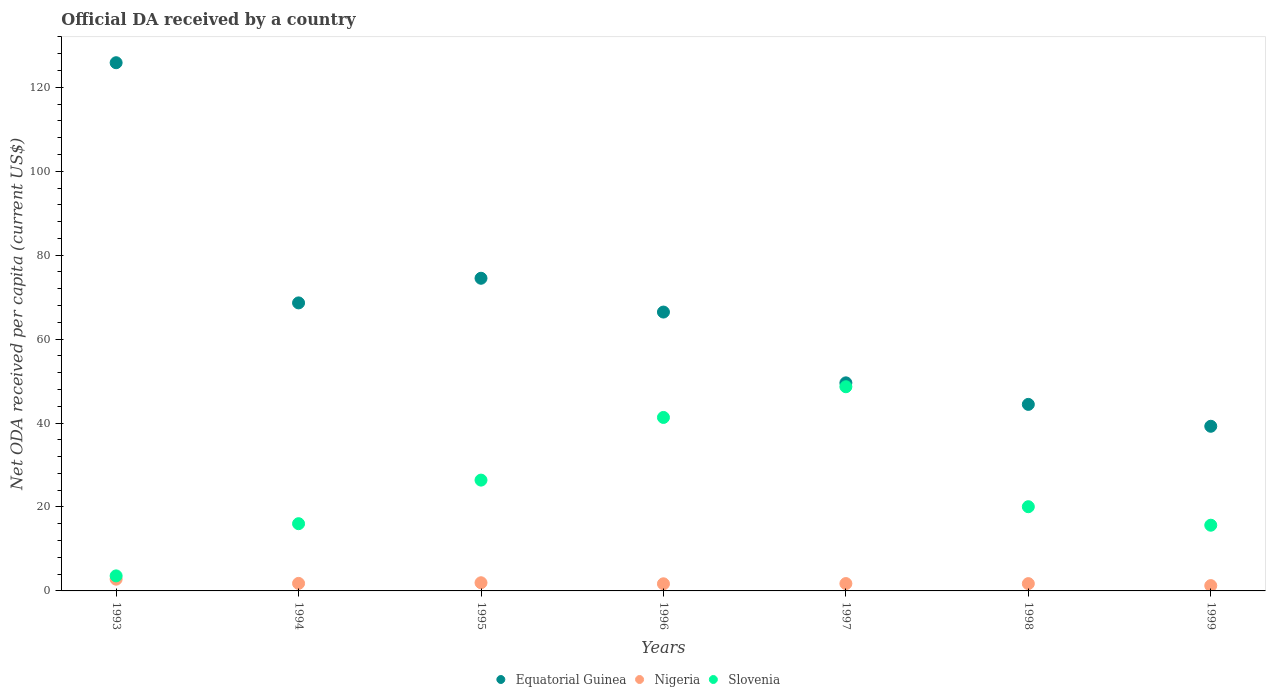How many different coloured dotlines are there?
Your answer should be very brief. 3. What is the ODA received in in Nigeria in 1998?
Provide a succinct answer. 1.74. Across all years, what is the maximum ODA received in in Equatorial Guinea?
Make the answer very short. 125.86. Across all years, what is the minimum ODA received in in Slovenia?
Provide a short and direct response. 3.58. In which year was the ODA received in in Slovenia minimum?
Provide a short and direct response. 1993. What is the total ODA received in in Nigeria in the graph?
Your answer should be very brief. 12.99. What is the difference between the ODA received in in Slovenia in 1993 and that in 1999?
Ensure brevity in your answer.  -12.07. What is the difference between the ODA received in in Nigeria in 1993 and the ODA received in in Equatorial Guinea in 1994?
Ensure brevity in your answer.  -65.83. What is the average ODA received in in Equatorial Guinea per year?
Keep it short and to the point. 66.96. In the year 1993, what is the difference between the ODA received in in Slovenia and ODA received in in Nigeria?
Provide a succinct answer. 0.79. In how many years, is the ODA received in in Slovenia greater than 56 US$?
Your response must be concise. 0. What is the ratio of the ODA received in in Nigeria in 1994 to that in 1997?
Offer a terse response. 1.02. Is the difference between the ODA received in in Slovenia in 1996 and 1997 greater than the difference between the ODA received in in Nigeria in 1996 and 1997?
Ensure brevity in your answer.  No. What is the difference between the highest and the second highest ODA received in in Nigeria?
Make the answer very short. 0.85. What is the difference between the highest and the lowest ODA received in in Slovenia?
Ensure brevity in your answer.  45.07. Is it the case that in every year, the sum of the ODA received in in Nigeria and ODA received in in Equatorial Guinea  is greater than the ODA received in in Slovenia?
Provide a succinct answer. Yes. How many years are there in the graph?
Offer a terse response. 7. Does the graph contain grids?
Ensure brevity in your answer.  No. How many legend labels are there?
Give a very brief answer. 3. How are the legend labels stacked?
Your answer should be compact. Horizontal. What is the title of the graph?
Provide a short and direct response. Official DA received by a country. Does "Micronesia" appear as one of the legend labels in the graph?
Keep it short and to the point. No. What is the label or title of the X-axis?
Your response must be concise. Years. What is the label or title of the Y-axis?
Offer a very short reply. Net ODA received per capita (current US$). What is the Net ODA received per capita (current US$) of Equatorial Guinea in 1993?
Provide a succinct answer. 125.86. What is the Net ODA received per capita (current US$) of Nigeria in 1993?
Provide a succinct answer. 2.8. What is the Net ODA received per capita (current US$) in Slovenia in 1993?
Your answer should be very brief. 3.58. What is the Net ODA received per capita (current US$) of Equatorial Guinea in 1994?
Offer a terse response. 68.63. What is the Net ODA received per capita (current US$) of Nigeria in 1994?
Your response must be concise. 1.79. What is the Net ODA received per capita (current US$) of Slovenia in 1994?
Your answer should be very brief. 16.02. What is the Net ODA received per capita (current US$) in Equatorial Guinea in 1995?
Provide a succinct answer. 74.5. What is the Net ODA received per capita (current US$) in Nigeria in 1995?
Your response must be concise. 1.95. What is the Net ODA received per capita (current US$) of Slovenia in 1995?
Provide a succinct answer. 26.4. What is the Net ODA received per capita (current US$) of Equatorial Guinea in 1996?
Your response must be concise. 66.44. What is the Net ODA received per capita (current US$) of Nigeria in 1996?
Your answer should be very brief. 1.7. What is the Net ODA received per capita (current US$) in Slovenia in 1996?
Your answer should be compact. 41.34. What is the Net ODA received per capita (current US$) of Equatorial Guinea in 1997?
Your answer should be compact. 49.58. What is the Net ODA received per capita (current US$) in Nigeria in 1997?
Make the answer very short. 1.75. What is the Net ODA received per capita (current US$) of Slovenia in 1997?
Make the answer very short. 48.65. What is the Net ODA received per capita (current US$) of Equatorial Guinea in 1998?
Ensure brevity in your answer.  44.45. What is the Net ODA received per capita (current US$) in Nigeria in 1998?
Provide a short and direct response. 1.74. What is the Net ODA received per capita (current US$) in Slovenia in 1998?
Offer a very short reply. 20.06. What is the Net ODA received per capita (current US$) in Equatorial Guinea in 1999?
Provide a succinct answer. 39.23. What is the Net ODA received per capita (current US$) in Nigeria in 1999?
Your answer should be very brief. 1.27. What is the Net ODA received per capita (current US$) in Slovenia in 1999?
Ensure brevity in your answer.  15.66. Across all years, what is the maximum Net ODA received per capita (current US$) of Equatorial Guinea?
Your answer should be very brief. 125.86. Across all years, what is the maximum Net ODA received per capita (current US$) in Nigeria?
Your answer should be compact. 2.8. Across all years, what is the maximum Net ODA received per capita (current US$) of Slovenia?
Make the answer very short. 48.65. Across all years, what is the minimum Net ODA received per capita (current US$) in Equatorial Guinea?
Offer a terse response. 39.23. Across all years, what is the minimum Net ODA received per capita (current US$) in Nigeria?
Your answer should be very brief. 1.27. Across all years, what is the minimum Net ODA received per capita (current US$) of Slovenia?
Offer a very short reply. 3.58. What is the total Net ODA received per capita (current US$) of Equatorial Guinea in the graph?
Give a very brief answer. 468.69. What is the total Net ODA received per capita (current US$) in Nigeria in the graph?
Your answer should be very brief. 12.99. What is the total Net ODA received per capita (current US$) in Slovenia in the graph?
Ensure brevity in your answer.  171.72. What is the difference between the Net ODA received per capita (current US$) of Equatorial Guinea in 1993 and that in 1994?
Ensure brevity in your answer.  57.23. What is the difference between the Net ODA received per capita (current US$) in Slovenia in 1993 and that in 1994?
Provide a short and direct response. -12.43. What is the difference between the Net ODA received per capita (current US$) in Equatorial Guinea in 1993 and that in 1995?
Give a very brief answer. 51.36. What is the difference between the Net ODA received per capita (current US$) of Nigeria in 1993 and that in 1995?
Your answer should be very brief. 0.85. What is the difference between the Net ODA received per capita (current US$) in Slovenia in 1993 and that in 1995?
Your answer should be compact. -22.82. What is the difference between the Net ODA received per capita (current US$) in Equatorial Guinea in 1993 and that in 1996?
Keep it short and to the point. 59.41. What is the difference between the Net ODA received per capita (current US$) in Nigeria in 1993 and that in 1996?
Your response must be concise. 1.1. What is the difference between the Net ODA received per capita (current US$) in Slovenia in 1993 and that in 1996?
Your response must be concise. -37.75. What is the difference between the Net ODA received per capita (current US$) of Equatorial Guinea in 1993 and that in 1997?
Make the answer very short. 76.28. What is the difference between the Net ODA received per capita (current US$) in Nigeria in 1993 and that in 1997?
Give a very brief answer. 1.04. What is the difference between the Net ODA received per capita (current US$) in Slovenia in 1993 and that in 1997?
Offer a terse response. -45.07. What is the difference between the Net ODA received per capita (current US$) in Equatorial Guinea in 1993 and that in 1998?
Keep it short and to the point. 81.41. What is the difference between the Net ODA received per capita (current US$) of Nigeria in 1993 and that in 1998?
Offer a terse response. 1.06. What is the difference between the Net ODA received per capita (current US$) in Slovenia in 1993 and that in 1998?
Your answer should be very brief. -16.48. What is the difference between the Net ODA received per capita (current US$) of Equatorial Guinea in 1993 and that in 1999?
Ensure brevity in your answer.  86.62. What is the difference between the Net ODA received per capita (current US$) in Nigeria in 1993 and that in 1999?
Give a very brief answer. 1.53. What is the difference between the Net ODA received per capita (current US$) in Slovenia in 1993 and that in 1999?
Offer a terse response. -12.07. What is the difference between the Net ODA received per capita (current US$) in Equatorial Guinea in 1994 and that in 1995?
Ensure brevity in your answer.  -5.87. What is the difference between the Net ODA received per capita (current US$) of Nigeria in 1994 and that in 1995?
Keep it short and to the point. -0.15. What is the difference between the Net ODA received per capita (current US$) of Slovenia in 1994 and that in 1995?
Give a very brief answer. -10.38. What is the difference between the Net ODA received per capita (current US$) of Equatorial Guinea in 1994 and that in 1996?
Offer a very short reply. 2.18. What is the difference between the Net ODA received per capita (current US$) in Nigeria in 1994 and that in 1996?
Give a very brief answer. 0.1. What is the difference between the Net ODA received per capita (current US$) of Slovenia in 1994 and that in 1996?
Give a very brief answer. -25.32. What is the difference between the Net ODA received per capita (current US$) in Equatorial Guinea in 1994 and that in 1997?
Offer a very short reply. 19.05. What is the difference between the Net ODA received per capita (current US$) in Nigeria in 1994 and that in 1997?
Provide a succinct answer. 0.04. What is the difference between the Net ODA received per capita (current US$) of Slovenia in 1994 and that in 1997?
Ensure brevity in your answer.  -32.63. What is the difference between the Net ODA received per capita (current US$) in Equatorial Guinea in 1994 and that in 1998?
Provide a succinct answer. 24.18. What is the difference between the Net ODA received per capita (current US$) in Nigeria in 1994 and that in 1998?
Give a very brief answer. 0.06. What is the difference between the Net ODA received per capita (current US$) of Slovenia in 1994 and that in 1998?
Your answer should be compact. -4.04. What is the difference between the Net ODA received per capita (current US$) in Equatorial Guinea in 1994 and that in 1999?
Your answer should be compact. 29.4. What is the difference between the Net ODA received per capita (current US$) of Nigeria in 1994 and that in 1999?
Offer a very short reply. 0.53. What is the difference between the Net ODA received per capita (current US$) of Slovenia in 1994 and that in 1999?
Make the answer very short. 0.36. What is the difference between the Net ODA received per capita (current US$) of Equatorial Guinea in 1995 and that in 1996?
Provide a succinct answer. 8.05. What is the difference between the Net ODA received per capita (current US$) of Nigeria in 1995 and that in 1996?
Provide a short and direct response. 0.25. What is the difference between the Net ODA received per capita (current US$) in Slovenia in 1995 and that in 1996?
Provide a short and direct response. -14.93. What is the difference between the Net ODA received per capita (current US$) in Equatorial Guinea in 1995 and that in 1997?
Offer a terse response. 24.92. What is the difference between the Net ODA received per capita (current US$) of Nigeria in 1995 and that in 1997?
Offer a terse response. 0.19. What is the difference between the Net ODA received per capita (current US$) in Slovenia in 1995 and that in 1997?
Your answer should be very brief. -22.25. What is the difference between the Net ODA received per capita (current US$) in Equatorial Guinea in 1995 and that in 1998?
Provide a short and direct response. 30.05. What is the difference between the Net ODA received per capita (current US$) of Nigeria in 1995 and that in 1998?
Your answer should be very brief. 0.21. What is the difference between the Net ODA received per capita (current US$) of Slovenia in 1995 and that in 1998?
Offer a very short reply. 6.34. What is the difference between the Net ODA received per capita (current US$) in Equatorial Guinea in 1995 and that in 1999?
Give a very brief answer. 35.27. What is the difference between the Net ODA received per capita (current US$) of Nigeria in 1995 and that in 1999?
Provide a succinct answer. 0.68. What is the difference between the Net ODA received per capita (current US$) of Slovenia in 1995 and that in 1999?
Ensure brevity in your answer.  10.75. What is the difference between the Net ODA received per capita (current US$) in Equatorial Guinea in 1996 and that in 1997?
Give a very brief answer. 16.87. What is the difference between the Net ODA received per capita (current US$) in Nigeria in 1996 and that in 1997?
Make the answer very short. -0.05. What is the difference between the Net ODA received per capita (current US$) of Slovenia in 1996 and that in 1997?
Give a very brief answer. -7.32. What is the difference between the Net ODA received per capita (current US$) of Equatorial Guinea in 1996 and that in 1998?
Offer a very short reply. 22. What is the difference between the Net ODA received per capita (current US$) of Nigeria in 1996 and that in 1998?
Give a very brief answer. -0.04. What is the difference between the Net ODA received per capita (current US$) in Slovenia in 1996 and that in 1998?
Your answer should be very brief. 21.27. What is the difference between the Net ODA received per capita (current US$) in Equatorial Guinea in 1996 and that in 1999?
Ensure brevity in your answer.  27.21. What is the difference between the Net ODA received per capita (current US$) in Nigeria in 1996 and that in 1999?
Keep it short and to the point. 0.43. What is the difference between the Net ODA received per capita (current US$) in Slovenia in 1996 and that in 1999?
Offer a very short reply. 25.68. What is the difference between the Net ODA received per capita (current US$) in Equatorial Guinea in 1997 and that in 1998?
Your answer should be compact. 5.13. What is the difference between the Net ODA received per capita (current US$) in Nigeria in 1997 and that in 1998?
Offer a very short reply. 0.01. What is the difference between the Net ODA received per capita (current US$) of Slovenia in 1997 and that in 1998?
Provide a succinct answer. 28.59. What is the difference between the Net ODA received per capita (current US$) in Equatorial Guinea in 1997 and that in 1999?
Keep it short and to the point. 10.35. What is the difference between the Net ODA received per capita (current US$) of Nigeria in 1997 and that in 1999?
Your answer should be very brief. 0.49. What is the difference between the Net ODA received per capita (current US$) of Slovenia in 1997 and that in 1999?
Ensure brevity in your answer.  32.99. What is the difference between the Net ODA received per capita (current US$) of Equatorial Guinea in 1998 and that in 1999?
Your response must be concise. 5.21. What is the difference between the Net ODA received per capita (current US$) in Nigeria in 1998 and that in 1999?
Your answer should be very brief. 0.47. What is the difference between the Net ODA received per capita (current US$) in Slovenia in 1998 and that in 1999?
Offer a terse response. 4.41. What is the difference between the Net ODA received per capita (current US$) in Equatorial Guinea in 1993 and the Net ODA received per capita (current US$) in Nigeria in 1994?
Offer a terse response. 124.06. What is the difference between the Net ODA received per capita (current US$) in Equatorial Guinea in 1993 and the Net ODA received per capita (current US$) in Slovenia in 1994?
Offer a very short reply. 109.84. What is the difference between the Net ODA received per capita (current US$) of Nigeria in 1993 and the Net ODA received per capita (current US$) of Slovenia in 1994?
Keep it short and to the point. -13.22. What is the difference between the Net ODA received per capita (current US$) of Equatorial Guinea in 1993 and the Net ODA received per capita (current US$) of Nigeria in 1995?
Offer a very short reply. 123.91. What is the difference between the Net ODA received per capita (current US$) in Equatorial Guinea in 1993 and the Net ODA received per capita (current US$) in Slovenia in 1995?
Keep it short and to the point. 99.45. What is the difference between the Net ODA received per capita (current US$) of Nigeria in 1993 and the Net ODA received per capita (current US$) of Slovenia in 1995?
Ensure brevity in your answer.  -23.61. What is the difference between the Net ODA received per capita (current US$) in Equatorial Guinea in 1993 and the Net ODA received per capita (current US$) in Nigeria in 1996?
Offer a very short reply. 124.16. What is the difference between the Net ODA received per capita (current US$) of Equatorial Guinea in 1993 and the Net ODA received per capita (current US$) of Slovenia in 1996?
Your answer should be very brief. 84.52. What is the difference between the Net ODA received per capita (current US$) of Nigeria in 1993 and the Net ODA received per capita (current US$) of Slovenia in 1996?
Keep it short and to the point. -38.54. What is the difference between the Net ODA received per capita (current US$) of Equatorial Guinea in 1993 and the Net ODA received per capita (current US$) of Nigeria in 1997?
Offer a terse response. 124.11. What is the difference between the Net ODA received per capita (current US$) in Equatorial Guinea in 1993 and the Net ODA received per capita (current US$) in Slovenia in 1997?
Make the answer very short. 77.21. What is the difference between the Net ODA received per capita (current US$) of Nigeria in 1993 and the Net ODA received per capita (current US$) of Slovenia in 1997?
Offer a terse response. -45.86. What is the difference between the Net ODA received per capita (current US$) of Equatorial Guinea in 1993 and the Net ODA received per capita (current US$) of Nigeria in 1998?
Your answer should be very brief. 124.12. What is the difference between the Net ODA received per capita (current US$) in Equatorial Guinea in 1993 and the Net ODA received per capita (current US$) in Slovenia in 1998?
Ensure brevity in your answer.  105.79. What is the difference between the Net ODA received per capita (current US$) in Nigeria in 1993 and the Net ODA received per capita (current US$) in Slovenia in 1998?
Provide a succinct answer. -17.27. What is the difference between the Net ODA received per capita (current US$) of Equatorial Guinea in 1993 and the Net ODA received per capita (current US$) of Nigeria in 1999?
Provide a succinct answer. 124.59. What is the difference between the Net ODA received per capita (current US$) of Equatorial Guinea in 1993 and the Net ODA received per capita (current US$) of Slovenia in 1999?
Offer a very short reply. 110.2. What is the difference between the Net ODA received per capita (current US$) of Nigeria in 1993 and the Net ODA received per capita (current US$) of Slovenia in 1999?
Give a very brief answer. -12.86. What is the difference between the Net ODA received per capita (current US$) of Equatorial Guinea in 1994 and the Net ODA received per capita (current US$) of Nigeria in 1995?
Ensure brevity in your answer.  66.68. What is the difference between the Net ODA received per capita (current US$) of Equatorial Guinea in 1994 and the Net ODA received per capita (current US$) of Slovenia in 1995?
Your answer should be compact. 42.23. What is the difference between the Net ODA received per capita (current US$) of Nigeria in 1994 and the Net ODA received per capita (current US$) of Slovenia in 1995?
Offer a very short reply. -24.61. What is the difference between the Net ODA received per capita (current US$) of Equatorial Guinea in 1994 and the Net ODA received per capita (current US$) of Nigeria in 1996?
Offer a terse response. 66.93. What is the difference between the Net ODA received per capita (current US$) of Equatorial Guinea in 1994 and the Net ODA received per capita (current US$) of Slovenia in 1996?
Ensure brevity in your answer.  27.29. What is the difference between the Net ODA received per capita (current US$) in Nigeria in 1994 and the Net ODA received per capita (current US$) in Slovenia in 1996?
Your answer should be compact. -39.54. What is the difference between the Net ODA received per capita (current US$) of Equatorial Guinea in 1994 and the Net ODA received per capita (current US$) of Nigeria in 1997?
Offer a very short reply. 66.88. What is the difference between the Net ODA received per capita (current US$) in Equatorial Guinea in 1994 and the Net ODA received per capita (current US$) in Slovenia in 1997?
Keep it short and to the point. 19.98. What is the difference between the Net ODA received per capita (current US$) in Nigeria in 1994 and the Net ODA received per capita (current US$) in Slovenia in 1997?
Provide a succinct answer. -46.86. What is the difference between the Net ODA received per capita (current US$) of Equatorial Guinea in 1994 and the Net ODA received per capita (current US$) of Nigeria in 1998?
Keep it short and to the point. 66.89. What is the difference between the Net ODA received per capita (current US$) of Equatorial Guinea in 1994 and the Net ODA received per capita (current US$) of Slovenia in 1998?
Make the answer very short. 48.56. What is the difference between the Net ODA received per capita (current US$) of Nigeria in 1994 and the Net ODA received per capita (current US$) of Slovenia in 1998?
Your response must be concise. -18.27. What is the difference between the Net ODA received per capita (current US$) of Equatorial Guinea in 1994 and the Net ODA received per capita (current US$) of Nigeria in 1999?
Your response must be concise. 67.36. What is the difference between the Net ODA received per capita (current US$) in Equatorial Guinea in 1994 and the Net ODA received per capita (current US$) in Slovenia in 1999?
Provide a short and direct response. 52.97. What is the difference between the Net ODA received per capita (current US$) of Nigeria in 1994 and the Net ODA received per capita (current US$) of Slovenia in 1999?
Your response must be concise. -13.86. What is the difference between the Net ODA received per capita (current US$) of Equatorial Guinea in 1995 and the Net ODA received per capita (current US$) of Nigeria in 1996?
Keep it short and to the point. 72.8. What is the difference between the Net ODA received per capita (current US$) in Equatorial Guinea in 1995 and the Net ODA received per capita (current US$) in Slovenia in 1996?
Offer a very short reply. 33.16. What is the difference between the Net ODA received per capita (current US$) of Nigeria in 1995 and the Net ODA received per capita (current US$) of Slovenia in 1996?
Make the answer very short. -39.39. What is the difference between the Net ODA received per capita (current US$) of Equatorial Guinea in 1995 and the Net ODA received per capita (current US$) of Nigeria in 1997?
Provide a short and direct response. 72.75. What is the difference between the Net ODA received per capita (current US$) in Equatorial Guinea in 1995 and the Net ODA received per capita (current US$) in Slovenia in 1997?
Your answer should be very brief. 25.85. What is the difference between the Net ODA received per capita (current US$) in Nigeria in 1995 and the Net ODA received per capita (current US$) in Slovenia in 1997?
Provide a succinct answer. -46.71. What is the difference between the Net ODA received per capita (current US$) in Equatorial Guinea in 1995 and the Net ODA received per capita (current US$) in Nigeria in 1998?
Your answer should be very brief. 72.76. What is the difference between the Net ODA received per capita (current US$) of Equatorial Guinea in 1995 and the Net ODA received per capita (current US$) of Slovenia in 1998?
Give a very brief answer. 54.43. What is the difference between the Net ODA received per capita (current US$) of Nigeria in 1995 and the Net ODA received per capita (current US$) of Slovenia in 1998?
Your response must be concise. -18.12. What is the difference between the Net ODA received per capita (current US$) of Equatorial Guinea in 1995 and the Net ODA received per capita (current US$) of Nigeria in 1999?
Keep it short and to the point. 73.23. What is the difference between the Net ODA received per capita (current US$) in Equatorial Guinea in 1995 and the Net ODA received per capita (current US$) in Slovenia in 1999?
Provide a succinct answer. 58.84. What is the difference between the Net ODA received per capita (current US$) of Nigeria in 1995 and the Net ODA received per capita (current US$) of Slovenia in 1999?
Your answer should be compact. -13.71. What is the difference between the Net ODA received per capita (current US$) of Equatorial Guinea in 1996 and the Net ODA received per capita (current US$) of Nigeria in 1997?
Offer a very short reply. 64.69. What is the difference between the Net ODA received per capita (current US$) in Equatorial Guinea in 1996 and the Net ODA received per capita (current US$) in Slovenia in 1997?
Provide a short and direct response. 17.79. What is the difference between the Net ODA received per capita (current US$) of Nigeria in 1996 and the Net ODA received per capita (current US$) of Slovenia in 1997?
Your answer should be compact. -46.95. What is the difference between the Net ODA received per capita (current US$) in Equatorial Guinea in 1996 and the Net ODA received per capita (current US$) in Nigeria in 1998?
Ensure brevity in your answer.  64.71. What is the difference between the Net ODA received per capita (current US$) in Equatorial Guinea in 1996 and the Net ODA received per capita (current US$) in Slovenia in 1998?
Ensure brevity in your answer.  46.38. What is the difference between the Net ODA received per capita (current US$) of Nigeria in 1996 and the Net ODA received per capita (current US$) of Slovenia in 1998?
Provide a short and direct response. -18.37. What is the difference between the Net ODA received per capita (current US$) in Equatorial Guinea in 1996 and the Net ODA received per capita (current US$) in Nigeria in 1999?
Your response must be concise. 65.18. What is the difference between the Net ODA received per capita (current US$) of Equatorial Guinea in 1996 and the Net ODA received per capita (current US$) of Slovenia in 1999?
Provide a succinct answer. 50.79. What is the difference between the Net ODA received per capita (current US$) of Nigeria in 1996 and the Net ODA received per capita (current US$) of Slovenia in 1999?
Offer a terse response. -13.96. What is the difference between the Net ODA received per capita (current US$) of Equatorial Guinea in 1997 and the Net ODA received per capita (current US$) of Nigeria in 1998?
Ensure brevity in your answer.  47.84. What is the difference between the Net ODA received per capita (current US$) in Equatorial Guinea in 1997 and the Net ODA received per capita (current US$) in Slovenia in 1998?
Provide a short and direct response. 29.52. What is the difference between the Net ODA received per capita (current US$) of Nigeria in 1997 and the Net ODA received per capita (current US$) of Slovenia in 1998?
Give a very brief answer. -18.31. What is the difference between the Net ODA received per capita (current US$) of Equatorial Guinea in 1997 and the Net ODA received per capita (current US$) of Nigeria in 1999?
Your answer should be very brief. 48.31. What is the difference between the Net ODA received per capita (current US$) in Equatorial Guinea in 1997 and the Net ODA received per capita (current US$) in Slovenia in 1999?
Your answer should be very brief. 33.92. What is the difference between the Net ODA received per capita (current US$) in Nigeria in 1997 and the Net ODA received per capita (current US$) in Slovenia in 1999?
Provide a succinct answer. -13.91. What is the difference between the Net ODA received per capita (current US$) of Equatorial Guinea in 1998 and the Net ODA received per capita (current US$) of Nigeria in 1999?
Ensure brevity in your answer.  43.18. What is the difference between the Net ODA received per capita (current US$) in Equatorial Guinea in 1998 and the Net ODA received per capita (current US$) in Slovenia in 1999?
Give a very brief answer. 28.79. What is the difference between the Net ODA received per capita (current US$) in Nigeria in 1998 and the Net ODA received per capita (current US$) in Slovenia in 1999?
Make the answer very short. -13.92. What is the average Net ODA received per capita (current US$) in Equatorial Guinea per year?
Offer a very short reply. 66.96. What is the average Net ODA received per capita (current US$) in Nigeria per year?
Your answer should be very brief. 1.86. What is the average Net ODA received per capita (current US$) in Slovenia per year?
Ensure brevity in your answer.  24.53. In the year 1993, what is the difference between the Net ODA received per capita (current US$) in Equatorial Guinea and Net ODA received per capita (current US$) in Nigeria?
Ensure brevity in your answer.  123.06. In the year 1993, what is the difference between the Net ODA received per capita (current US$) of Equatorial Guinea and Net ODA received per capita (current US$) of Slovenia?
Your answer should be compact. 122.27. In the year 1993, what is the difference between the Net ODA received per capita (current US$) of Nigeria and Net ODA received per capita (current US$) of Slovenia?
Your answer should be very brief. -0.79. In the year 1994, what is the difference between the Net ODA received per capita (current US$) in Equatorial Guinea and Net ODA received per capita (current US$) in Nigeria?
Provide a short and direct response. 66.84. In the year 1994, what is the difference between the Net ODA received per capita (current US$) in Equatorial Guinea and Net ODA received per capita (current US$) in Slovenia?
Make the answer very short. 52.61. In the year 1994, what is the difference between the Net ODA received per capita (current US$) of Nigeria and Net ODA received per capita (current US$) of Slovenia?
Offer a terse response. -14.23. In the year 1995, what is the difference between the Net ODA received per capita (current US$) in Equatorial Guinea and Net ODA received per capita (current US$) in Nigeria?
Offer a very short reply. 72.55. In the year 1995, what is the difference between the Net ODA received per capita (current US$) in Equatorial Guinea and Net ODA received per capita (current US$) in Slovenia?
Your response must be concise. 48.09. In the year 1995, what is the difference between the Net ODA received per capita (current US$) of Nigeria and Net ODA received per capita (current US$) of Slovenia?
Your answer should be very brief. -24.46. In the year 1996, what is the difference between the Net ODA received per capita (current US$) in Equatorial Guinea and Net ODA received per capita (current US$) in Nigeria?
Provide a succinct answer. 64.75. In the year 1996, what is the difference between the Net ODA received per capita (current US$) of Equatorial Guinea and Net ODA received per capita (current US$) of Slovenia?
Give a very brief answer. 25.11. In the year 1996, what is the difference between the Net ODA received per capita (current US$) in Nigeria and Net ODA received per capita (current US$) in Slovenia?
Give a very brief answer. -39.64. In the year 1997, what is the difference between the Net ODA received per capita (current US$) of Equatorial Guinea and Net ODA received per capita (current US$) of Nigeria?
Provide a succinct answer. 47.83. In the year 1997, what is the difference between the Net ODA received per capita (current US$) of Equatorial Guinea and Net ODA received per capita (current US$) of Slovenia?
Your answer should be compact. 0.93. In the year 1997, what is the difference between the Net ODA received per capita (current US$) in Nigeria and Net ODA received per capita (current US$) in Slovenia?
Keep it short and to the point. -46.9. In the year 1998, what is the difference between the Net ODA received per capita (current US$) of Equatorial Guinea and Net ODA received per capita (current US$) of Nigeria?
Keep it short and to the point. 42.71. In the year 1998, what is the difference between the Net ODA received per capita (current US$) in Equatorial Guinea and Net ODA received per capita (current US$) in Slovenia?
Keep it short and to the point. 24.38. In the year 1998, what is the difference between the Net ODA received per capita (current US$) in Nigeria and Net ODA received per capita (current US$) in Slovenia?
Ensure brevity in your answer.  -18.33. In the year 1999, what is the difference between the Net ODA received per capita (current US$) of Equatorial Guinea and Net ODA received per capita (current US$) of Nigeria?
Your answer should be compact. 37.97. In the year 1999, what is the difference between the Net ODA received per capita (current US$) of Equatorial Guinea and Net ODA received per capita (current US$) of Slovenia?
Your response must be concise. 23.57. In the year 1999, what is the difference between the Net ODA received per capita (current US$) of Nigeria and Net ODA received per capita (current US$) of Slovenia?
Offer a terse response. -14.39. What is the ratio of the Net ODA received per capita (current US$) of Equatorial Guinea in 1993 to that in 1994?
Your answer should be compact. 1.83. What is the ratio of the Net ODA received per capita (current US$) of Nigeria in 1993 to that in 1994?
Your answer should be compact. 1.56. What is the ratio of the Net ODA received per capita (current US$) in Slovenia in 1993 to that in 1994?
Keep it short and to the point. 0.22. What is the ratio of the Net ODA received per capita (current US$) of Equatorial Guinea in 1993 to that in 1995?
Provide a succinct answer. 1.69. What is the ratio of the Net ODA received per capita (current US$) in Nigeria in 1993 to that in 1995?
Make the answer very short. 1.44. What is the ratio of the Net ODA received per capita (current US$) of Slovenia in 1993 to that in 1995?
Offer a very short reply. 0.14. What is the ratio of the Net ODA received per capita (current US$) of Equatorial Guinea in 1993 to that in 1996?
Your answer should be very brief. 1.89. What is the ratio of the Net ODA received per capita (current US$) in Nigeria in 1993 to that in 1996?
Your response must be concise. 1.65. What is the ratio of the Net ODA received per capita (current US$) of Slovenia in 1993 to that in 1996?
Give a very brief answer. 0.09. What is the ratio of the Net ODA received per capita (current US$) of Equatorial Guinea in 1993 to that in 1997?
Keep it short and to the point. 2.54. What is the ratio of the Net ODA received per capita (current US$) in Nigeria in 1993 to that in 1997?
Your response must be concise. 1.6. What is the ratio of the Net ODA received per capita (current US$) in Slovenia in 1993 to that in 1997?
Keep it short and to the point. 0.07. What is the ratio of the Net ODA received per capita (current US$) of Equatorial Guinea in 1993 to that in 1998?
Offer a terse response. 2.83. What is the ratio of the Net ODA received per capita (current US$) of Nigeria in 1993 to that in 1998?
Provide a succinct answer. 1.61. What is the ratio of the Net ODA received per capita (current US$) in Slovenia in 1993 to that in 1998?
Your response must be concise. 0.18. What is the ratio of the Net ODA received per capita (current US$) of Equatorial Guinea in 1993 to that in 1999?
Your response must be concise. 3.21. What is the ratio of the Net ODA received per capita (current US$) of Nigeria in 1993 to that in 1999?
Ensure brevity in your answer.  2.21. What is the ratio of the Net ODA received per capita (current US$) of Slovenia in 1993 to that in 1999?
Provide a succinct answer. 0.23. What is the ratio of the Net ODA received per capita (current US$) of Equatorial Guinea in 1994 to that in 1995?
Make the answer very short. 0.92. What is the ratio of the Net ODA received per capita (current US$) of Nigeria in 1994 to that in 1995?
Make the answer very short. 0.92. What is the ratio of the Net ODA received per capita (current US$) of Slovenia in 1994 to that in 1995?
Provide a succinct answer. 0.61. What is the ratio of the Net ODA received per capita (current US$) in Equatorial Guinea in 1994 to that in 1996?
Ensure brevity in your answer.  1.03. What is the ratio of the Net ODA received per capita (current US$) in Nigeria in 1994 to that in 1996?
Give a very brief answer. 1.06. What is the ratio of the Net ODA received per capita (current US$) of Slovenia in 1994 to that in 1996?
Your answer should be very brief. 0.39. What is the ratio of the Net ODA received per capita (current US$) in Equatorial Guinea in 1994 to that in 1997?
Your answer should be very brief. 1.38. What is the ratio of the Net ODA received per capita (current US$) of Nigeria in 1994 to that in 1997?
Ensure brevity in your answer.  1.02. What is the ratio of the Net ODA received per capita (current US$) of Slovenia in 1994 to that in 1997?
Provide a succinct answer. 0.33. What is the ratio of the Net ODA received per capita (current US$) in Equatorial Guinea in 1994 to that in 1998?
Keep it short and to the point. 1.54. What is the ratio of the Net ODA received per capita (current US$) of Nigeria in 1994 to that in 1998?
Your response must be concise. 1.03. What is the ratio of the Net ODA received per capita (current US$) of Slovenia in 1994 to that in 1998?
Your response must be concise. 0.8. What is the ratio of the Net ODA received per capita (current US$) in Equatorial Guinea in 1994 to that in 1999?
Offer a very short reply. 1.75. What is the ratio of the Net ODA received per capita (current US$) in Nigeria in 1994 to that in 1999?
Your answer should be compact. 1.42. What is the ratio of the Net ODA received per capita (current US$) in Slovenia in 1994 to that in 1999?
Your answer should be compact. 1.02. What is the ratio of the Net ODA received per capita (current US$) of Equatorial Guinea in 1995 to that in 1996?
Your response must be concise. 1.12. What is the ratio of the Net ODA received per capita (current US$) in Nigeria in 1995 to that in 1996?
Offer a very short reply. 1.15. What is the ratio of the Net ODA received per capita (current US$) in Slovenia in 1995 to that in 1996?
Your answer should be compact. 0.64. What is the ratio of the Net ODA received per capita (current US$) of Equatorial Guinea in 1995 to that in 1997?
Keep it short and to the point. 1.5. What is the ratio of the Net ODA received per capita (current US$) in Nigeria in 1995 to that in 1997?
Offer a terse response. 1.11. What is the ratio of the Net ODA received per capita (current US$) in Slovenia in 1995 to that in 1997?
Your response must be concise. 0.54. What is the ratio of the Net ODA received per capita (current US$) in Equatorial Guinea in 1995 to that in 1998?
Offer a terse response. 1.68. What is the ratio of the Net ODA received per capita (current US$) of Nigeria in 1995 to that in 1998?
Your response must be concise. 1.12. What is the ratio of the Net ODA received per capita (current US$) of Slovenia in 1995 to that in 1998?
Keep it short and to the point. 1.32. What is the ratio of the Net ODA received per capita (current US$) of Equatorial Guinea in 1995 to that in 1999?
Offer a very short reply. 1.9. What is the ratio of the Net ODA received per capita (current US$) of Nigeria in 1995 to that in 1999?
Offer a terse response. 1.54. What is the ratio of the Net ODA received per capita (current US$) of Slovenia in 1995 to that in 1999?
Your answer should be very brief. 1.69. What is the ratio of the Net ODA received per capita (current US$) in Equatorial Guinea in 1996 to that in 1997?
Offer a terse response. 1.34. What is the ratio of the Net ODA received per capita (current US$) of Nigeria in 1996 to that in 1997?
Give a very brief answer. 0.97. What is the ratio of the Net ODA received per capita (current US$) in Slovenia in 1996 to that in 1997?
Keep it short and to the point. 0.85. What is the ratio of the Net ODA received per capita (current US$) of Equatorial Guinea in 1996 to that in 1998?
Your response must be concise. 1.49. What is the ratio of the Net ODA received per capita (current US$) of Nigeria in 1996 to that in 1998?
Offer a very short reply. 0.98. What is the ratio of the Net ODA received per capita (current US$) of Slovenia in 1996 to that in 1998?
Offer a terse response. 2.06. What is the ratio of the Net ODA received per capita (current US$) of Equatorial Guinea in 1996 to that in 1999?
Your answer should be very brief. 1.69. What is the ratio of the Net ODA received per capita (current US$) in Nigeria in 1996 to that in 1999?
Provide a short and direct response. 1.34. What is the ratio of the Net ODA received per capita (current US$) of Slovenia in 1996 to that in 1999?
Offer a terse response. 2.64. What is the ratio of the Net ODA received per capita (current US$) in Equatorial Guinea in 1997 to that in 1998?
Give a very brief answer. 1.12. What is the ratio of the Net ODA received per capita (current US$) in Nigeria in 1997 to that in 1998?
Provide a succinct answer. 1.01. What is the ratio of the Net ODA received per capita (current US$) of Slovenia in 1997 to that in 1998?
Offer a terse response. 2.42. What is the ratio of the Net ODA received per capita (current US$) in Equatorial Guinea in 1997 to that in 1999?
Your answer should be compact. 1.26. What is the ratio of the Net ODA received per capita (current US$) in Nigeria in 1997 to that in 1999?
Keep it short and to the point. 1.38. What is the ratio of the Net ODA received per capita (current US$) in Slovenia in 1997 to that in 1999?
Keep it short and to the point. 3.11. What is the ratio of the Net ODA received per capita (current US$) of Equatorial Guinea in 1998 to that in 1999?
Give a very brief answer. 1.13. What is the ratio of the Net ODA received per capita (current US$) of Nigeria in 1998 to that in 1999?
Provide a succinct answer. 1.37. What is the ratio of the Net ODA received per capita (current US$) in Slovenia in 1998 to that in 1999?
Provide a short and direct response. 1.28. What is the difference between the highest and the second highest Net ODA received per capita (current US$) in Equatorial Guinea?
Provide a succinct answer. 51.36. What is the difference between the highest and the second highest Net ODA received per capita (current US$) in Nigeria?
Your response must be concise. 0.85. What is the difference between the highest and the second highest Net ODA received per capita (current US$) in Slovenia?
Offer a very short reply. 7.32. What is the difference between the highest and the lowest Net ODA received per capita (current US$) in Equatorial Guinea?
Offer a very short reply. 86.62. What is the difference between the highest and the lowest Net ODA received per capita (current US$) in Nigeria?
Ensure brevity in your answer.  1.53. What is the difference between the highest and the lowest Net ODA received per capita (current US$) in Slovenia?
Make the answer very short. 45.07. 